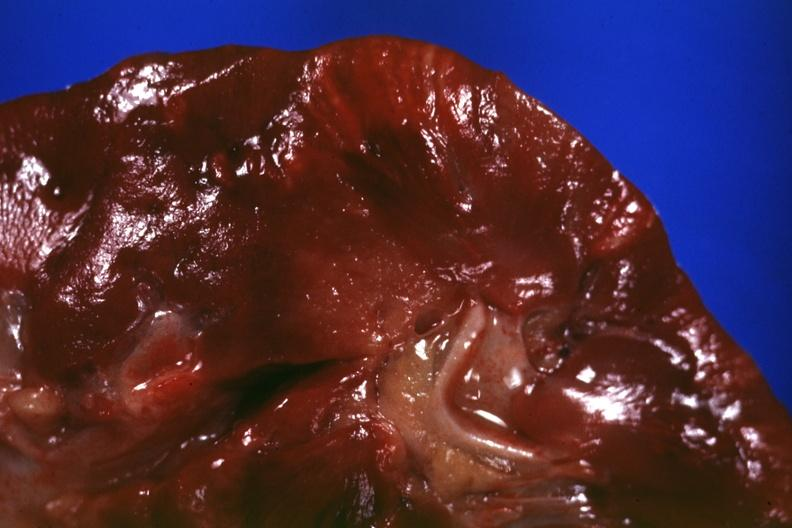what is present?
Answer the question using a single word or phrase. Sarcoidosis 